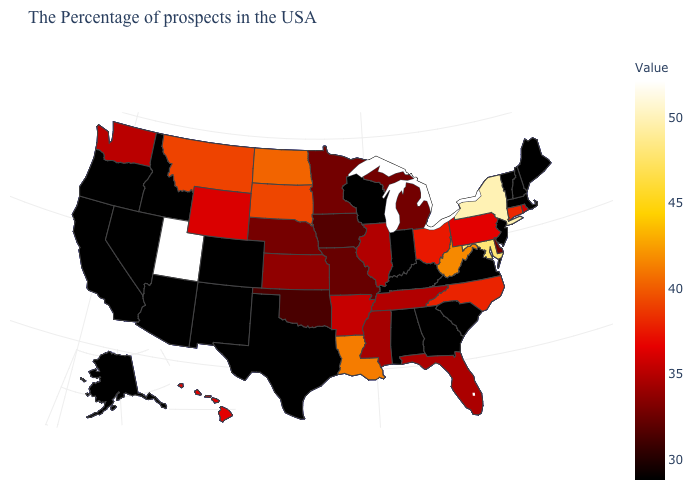Does North Carolina have a lower value than Maryland?
Give a very brief answer. Yes. Among the states that border Connecticut , which have the highest value?
Short answer required. New York. Does Montana have the lowest value in the USA?
Keep it brief. No. Which states hav the highest value in the MidWest?
Keep it brief. North Dakota. Among the states that border Minnesota , does Iowa have the lowest value?
Keep it brief. No. Which states have the lowest value in the USA?
Be succinct. Maine, Massachusetts, New Hampshire, Vermont, New Jersey, Virginia, South Carolina, Georgia, Kentucky, Indiana, Alabama, Wisconsin, Texas, Colorado, New Mexico, Arizona, Idaho, Nevada, California, Oregon, Alaska. Among the states that border New Jersey , does Delaware have the lowest value?
Answer briefly. Yes. Which states have the lowest value in the USA?
Concise answer only. Maine, Massachusetts, New Hampshire, Vermont, New Jersey, Virginia, South Carolina, Georgia, Kentucky, Indiana, Alabama, Wisconsin, Texas, Colorado, New Mexico, Arizona, Idaho, Nevada, California, Oregon, Alaska. 